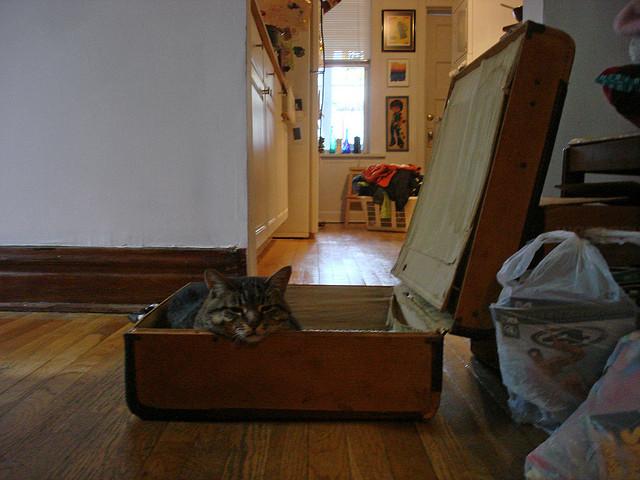What material is the floor made out of?
Write a very short answer. Wood. What superhero is on the blanket?
Answer briefly. Superman. Is the cat going on vacation?
Concise answer only. No. Is the cat relaxed?
Quick response, please. Yes. Is there a person in this picture?
Short answer required. No. Is the cat in a playful mood?
Short answer required. No. What animal is in the suitcase?
Be succinct. Cat. 